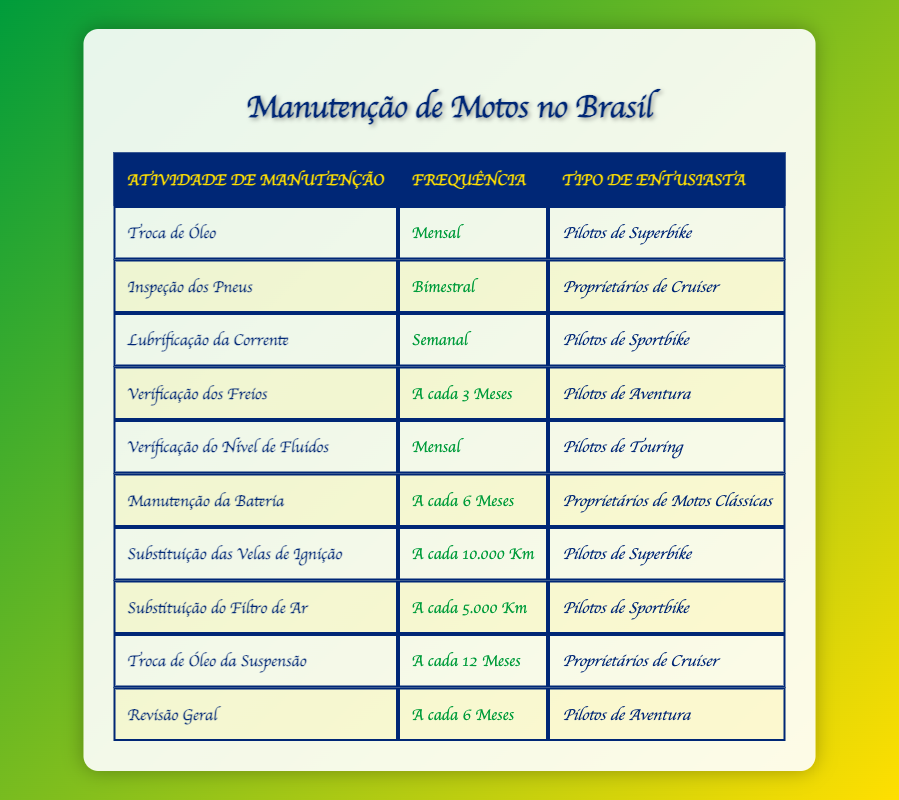What maintenance activity do Superbike Riders perform monthly? According to the table, Superbike Riders perform an "Oil Change" activity monthly. I can find this detail by looking for the row where the "EnthusiastType" is "Superbike Riders" and checking their corresponding "MaintenanceActivity" and "Frequency".
Answer: Oil Change How often do Cruiser Owners perform Tire Inspection? The table indicates that Cruiser Owners perform "Tire Inspection" activity Bi-Monthly. This can be answered by locating the row for "Cruiser Owners" and reading the frequency associated with their maintenance activity.
Answer: Bi-Monthly Do Adventure Riders perform any maintenance activities every 6 months? Yes, Adventure Riders perform "General Tune-Up" activity every 6 months. By scanning the table for the "EnthusiastType" of "Adventure Riders", I can find that their corresponding maintenance activity and frequency match that condition.
Answer: Yes Which maintenance activity is performed every 10,000 Km and by which type of enthusiast? The maintenance activity performed every 10,000 Km is "Spark Plug Replacement" by Superbike Riders. To derive this answer, I locate the row where the frequency matches "Every 10,000 Km" and check the corresponding "MaintenanceActivity" and "EnthusiastType".
Answer: Spark Plug Replacement by Superbike Riders What is the total number of maintenance activities performed by Sportbike Riders? Sportbike Riders perform two maintenance activities: "Chain Lubrication" weekly and "Air Filter Replacement" every 5,000 Km. By checking all rows for the "EnthusiastType" of "Sportbike Riders", I count these two activities to reach a total.
Answer: 2 